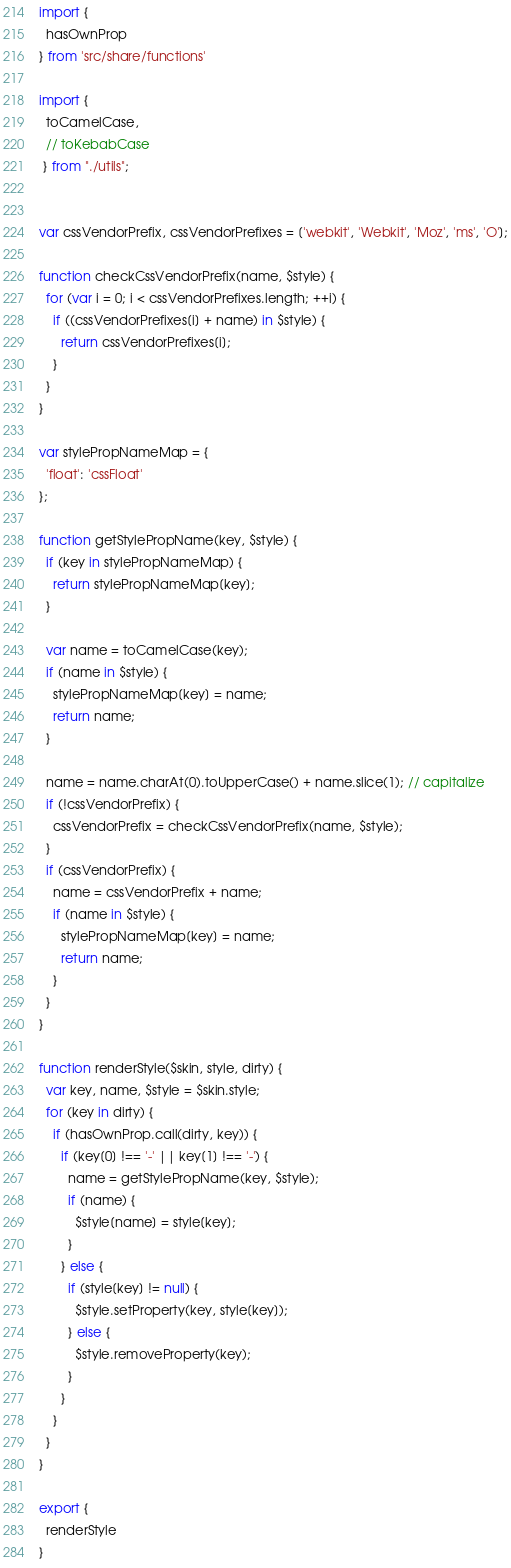Convert code to text. <code><loc_0><loc_0><loc_500><loc_500><_JavaScript_>import {
  hasOwnProp
} from 'src/share/functions'

import { 
  toCamelCase,
  // toKebabCase
 } from "./utils";

 
var cssVendorPrefix, cssVendorPrefixes = ['webkit', 'Webkit', 'Moz', 'ms', 'O'];

function checkCssVendorPrefix(name, $style) {
  for (var i = 0; i < cssVendorPrefixes.length; ++i) {
    if ((cssVendorPrefixes[i] + name) in $style) {
      return cssVendorPrefixes[i];
    }
  }
}

var stylePropNameMap = {
  'float': 'cssFloat'
};

function getStylePropName(key, $style) {
  if (key in stylePropNameMap) {
    return stylePropNameMap[key];
  }

  var name = toCamelCase(key);
  if (name in $style) {
    stylePropNameMap[key] = name;
    return name;
  }

  name = name.charAt(0).toUpperCase() + name.slice(1); // capitalize
  if (!cssVendorPrefix) {
    cssVendorPrefix = checkCssVendorPrefix(name, $style);
  }
  if (cssVendorPrefix) {
    name = cssVendorPrefix + name;
    if (name in $style) {
      stylePropNameMap[key] = name;
      return name;
    }
  }
}

function renderStyle($skin, style, dirty) {
  var key, name, $style = $skin.style;
  for (key in dirty) {
    if (hasOwnProp.call(dirty, key)) {
      if (key[0] !== '-' || key[1] !== '-') {
        name = getStylePropName(key, $style);
        if (name) {
          $style[name] = style[key];
        }
      } else {
        if (style[key] != null) {
          $style.setProperty(key, style[key]);
        } else {
          $style.removeProperty(key);
        }
      }
    }
  }
}

export {
  renderStyle
}</code> 